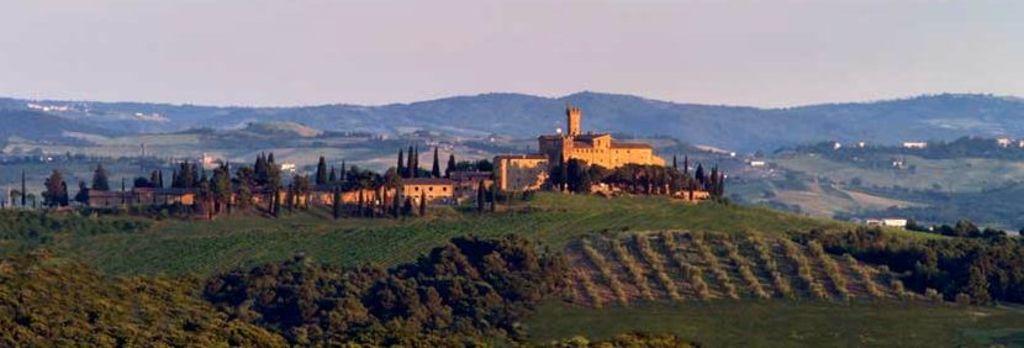Describe this image in one or two sentences. In the image there is a beautiful scenery, there is a lot of grass and trees and in between those trees there is a fort, behind a fort there are some mountains. 